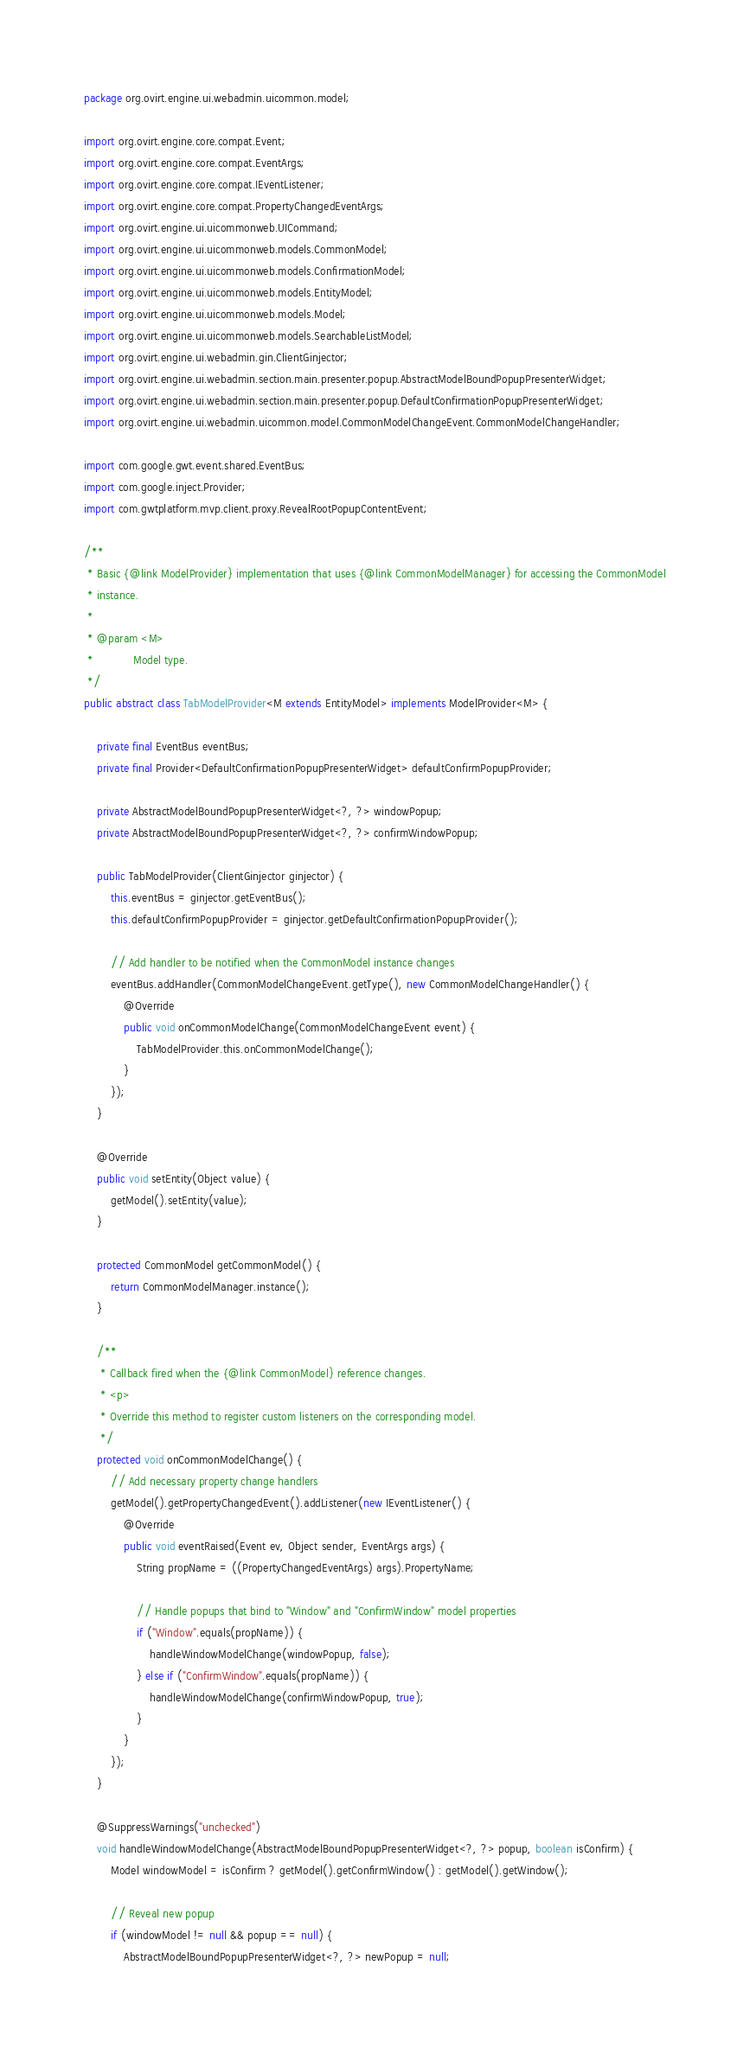<code> <loc_0><loc_0><loc_500><loc_500><_Java_>package org.ovirt.engine.ui.webadmin.uicommon.model;

import org.ovirt.engine.core.compat.Event;
import org.ovirt.engine.core.compat.EventArgs;
import org.ovirt.engine.core.compat.IEventListener;
import org.ovirt.engine.core.compat.PropertyChangedEventArgs;
import org.ovirt.engine.ui.uicommonweb.UICommand;
import org.ovirt.engine.ui.uicommonweb.models.CommonModel;
import org.ovirt.engine.ui.uicommonweb.models.ConfirmationModel;
import org.ovirt.engine.ui.uicommonweb.models.EntityModel;
import org.ovirt.engine.ui.uicommonweb.models.Model;
import org.ovirt.engine.ui.uicommonweb.models.SearchableListModel;
import org.ovirt.engine.ui.webadmin.gin.ClientGinjector;
import org.ovirt.engine.ui.webadmin.section.main.presenter.popup.AbstractModelBoundPopupPresenterWidget;
import org.ovirt.engine.ui.webadmin.section.main.presenter.popup.DefaultConfirmationPopupPresenterWidget;
import org.ovirt.engine.ui.webadmin.uicommon.model.CommonModelChangeEvent.CommonModelChangeHandler;

import com.google.gwt.event.shared.EventBus;
import com.google.inject.Provider;
import com.gwtplatform.mvp.client.proxy.RevealRootPopupContentEvent;

/**
 * Basic {@link ModelProvider} implementation that uses {@link CommonModelManager} for accessing the CommonModel
 * instance.
 * 
 * @param <M>
 *            Model type.
 */
public abstract class TabModelProvider<M extends EntityModel> implements ModelProvider<M> {

    private final EventBus eventBus;
    private final Provider<DefaultConfirmationPopupPresenterWidget> defaultConfirmPopupProvider;

    private AbstractModelBoundPopupPresenterWidget<?, ?> windowPopup;
    private AbstractModelBoundPopupPresenterWidget<?, ?> confirmWindowPopup;

    public TabModelProvider(ClientGinjector ginjector) {
        this.eventBus = ginjector.getEventBus();
        this.defaultConfirmPopupProvider = ginjector.getDefaultConfirmationPopupProvider();

        // Add handler to be notified when the CommonModel instance changes
        eventBus.addHandler(CommonModelChangeEvent.getType(), new CommonModelChangeHandler() {
            @Override
            public void onCommonModelChange(CommonModelChangeEvent event) {
                TabModelProvider.this.onCommonModelChange();
            }
        });
    }

    @Override
    public void setEntity(Object value) {
        getModel().setEntity(value);
    }

    protected CommonModel getCommonModel() {
        return CommonModelManager.instance();
    }

    /**
     * Callback fired when the {@link CommonModel} reference changes.
     * <p>
     * Override this method to register custom listeners on the corresponding model.
     */
    protected void onCommonModelChange() {
        // Add necessary property change handlers
        getModel().getPropertyChangedEvent().addListener(new IEventListener() {
            @Override
            public void eventRaised(Event ev, Object sender, EventArgs args) {
                String propName = ((PropertyChangedEventArgs) args).PropertyName;

                // Handle popups that bind to "Window" and "ConfirmWindow" model properties
                if ("Window".equals(propName)) {
                    handleWindowModelChange(windowPopup, false);
                } else if ("ConfirmWindow".equals(propName)) {
                    handleWindowModelChange(confirmWindowPopup, true);
                }
            }
        });
    }

    @SuppressWarnings("unchecked")
    void handleWindowModelChange(AbstractModelBoundPopupPresenterWidget<?, ?> popup, boolean isConfirm) {
        Model windowModel = isConfirm ? getModel().getConfirmWindow() : getModel().getWindow();

        // Reveal new popup
        if (windowModel != null && popup == null) {
            AbstractModelBoundPopupPresenterWidget<?, ?> newPopup = null;</code> 